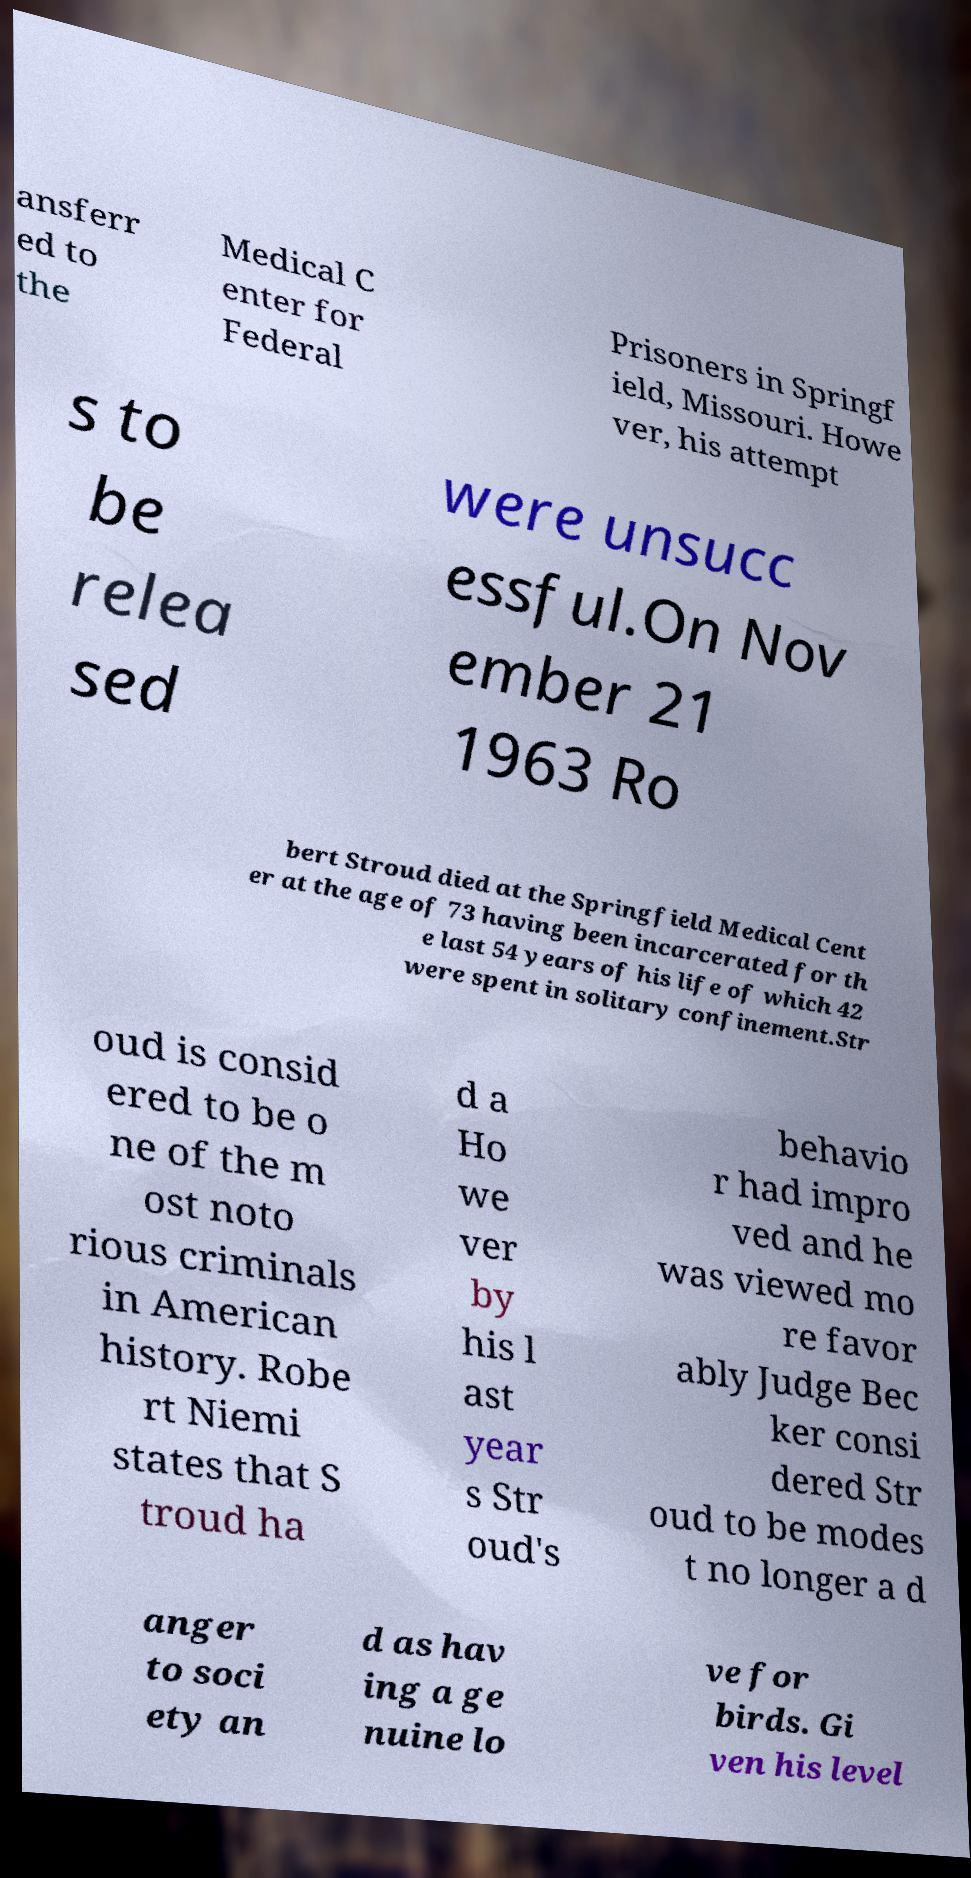There's text embedded in this image that I need extracted. Can you transcribe it verbatim? ansferr ed to the Medical C enter for Federal Prisoners in Springf ield, Missouri. Howe ver, his attempt s to be relea sed were unsucc essful.On Nov ember 21 1963 Ro bert Stroud died at the Springfield Medical Cent er at the age of 73 having been incarcerated for th e last 54 years of his life of which 42 were spent in solitary confinement.Str oud is consid ered to be o ne of the m ost noto rious criminals in American history. Robe rt Niemi states that S troud ha d a Ho we ver by his l ast year s Str oud's behavio r had impro ved and he was viewed mo re favor ably Judge Bec ker consi dered Str oud to be modes t no longer a d anger to soci ety an d as hav ing a ge nuine lo ve for birds. Gi ven his level 